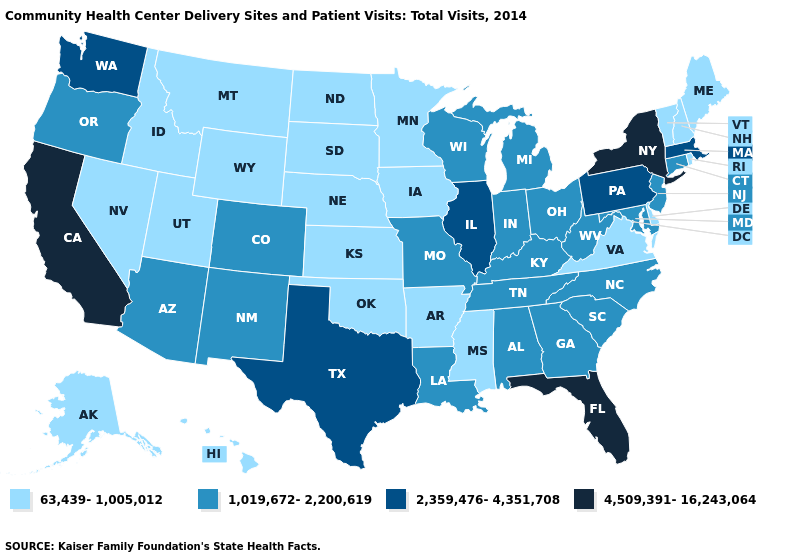Name the states that have a value in the range 4,509,391-16,243,064?
Short answer required. California, Florida, New York. Which states hav the highest value in the West?
Write a very short answer. California. Name the states that have a value in the range 63,439-1,005,012?
Answer briefly. Alaska, Arkansas, Delaware, Hawaii, Idaho, Iowa, Kansas, Maine, Minnesota, Mississippi, Montana, Nebraska, Nevada, New Hampshire, North Dakota, Oklahoma, Rhode Island, South Dakota, Utah, Vermont, Virginia, Wyoming. Does Kentucky have the highest value in the USA?
Write a very short answer. No. Name the states that have a value in the range 1,019,672-2,200,619?
Short answer required. Alabama, Arizona, Colorado, Connecticut, Georgia, Indiana, Kentucky, Louisiana, Maryland, Michigan, Missouri, New Jersey, New Mexico, North Carolina, Ohio, Oregon, South Carolina, Tennessee, West Virginia, Wisconsin. What is the lowest value in states that border Indiana?
Short answer required. 1,019,672-2,200,619. What is the value of Tennessee?
Quick response, please. 1,019,672-2,200,619. Which states have the lowest value in the Northeast?
Write a very short answer. Maine, New Hampshire, Rhode Island, Vermont. What is the highest value in states that border Idaho?
Keep it brief. 2,359,476-4,351,708. Name the states that have a value in the range 4,509,391-16,243,064?
Concise answer only. California, Florida, New York. Does Utah have a lower value than Maine?
Give a very brief answer. No. What is the value of North Carolina?
Answer briefly. 1,019,672-2,200,619. Does Rhode Island have the lowest value in the USA?
Answer briefly. Yes. What is the value of West Virginia?
Keep it brief. 1,019,672-2,200,619. Name the states that have a value in the range 2,359,476-4,351,708?
Answer briefly. Illinois, Massachusetts, Pennsylvania, Texas, Washington. 